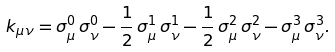Convert formula to latex. <formula><loc_0><loc_0><loc_500><loc_500>k _ { \mu \nu } = \sigma ^ { 0 } _ { \mu } \, \sigma ^ { 0 } _ { \nu } - \frac { 1 } { 2 } \, \sigma ^ { 1 } _ { \mu } \, \sigma ^ { 1 } _ { \nu } - \frac { 1 } { 2 } \, \sigma ^ { 2 } _ { \mu } \, \sigma ^ { 2 } _ { \nu } - \sigma ^ { 3 } _ { \mu } \, \sigma ^ { 3 } _ { \nu } .</formula> 